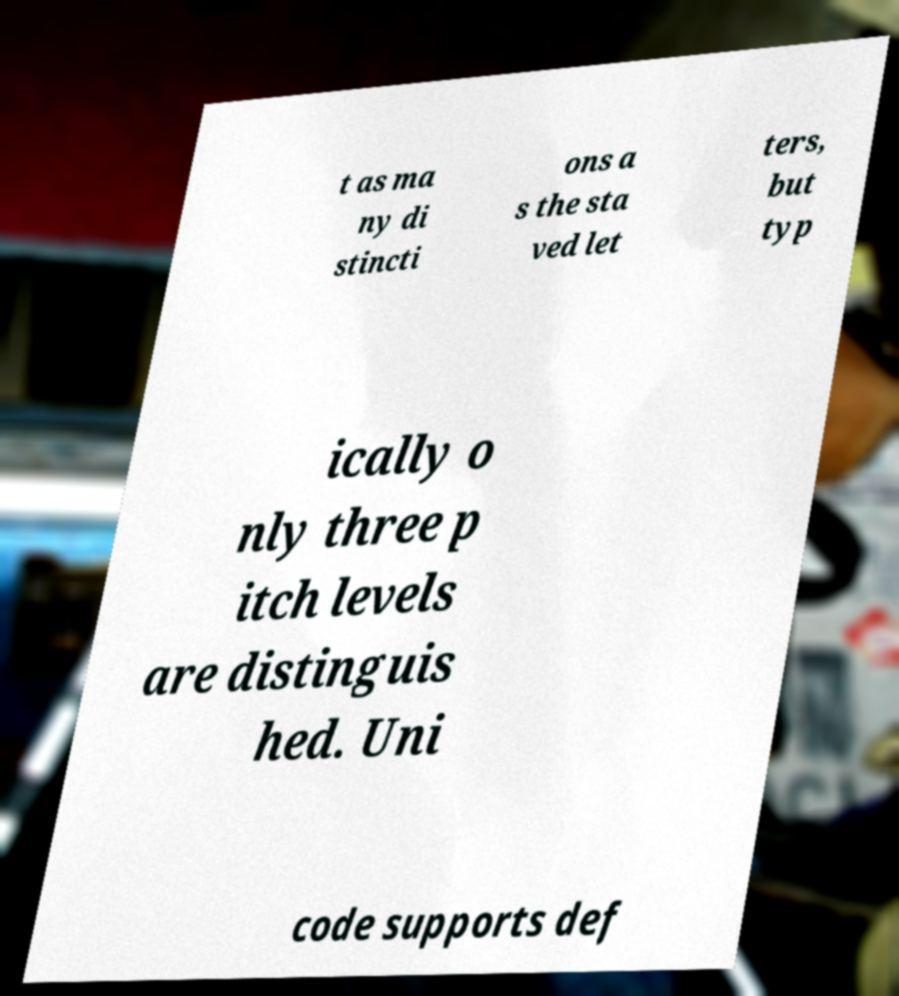Can you accurately transcribe the text from the provided image for me? t as ma ny di stincti ons a s the sta ved let ters, but typ ically o nly three p itch levels are distinguis hed. Uni code supports def 